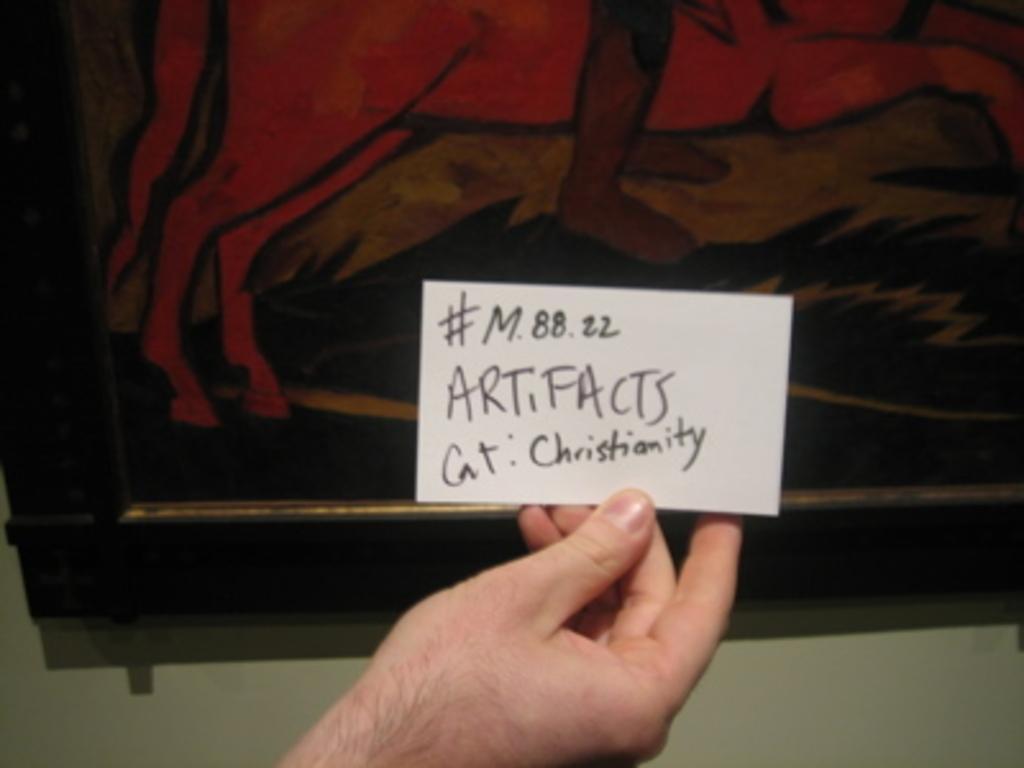How would you summarize this image in a sentence or two? In this picture, we see a hand of a person holding a white card with some text written on it. In the background, we see a white wall on which a photo frame is placed. This photo frame is in brown and black color. 